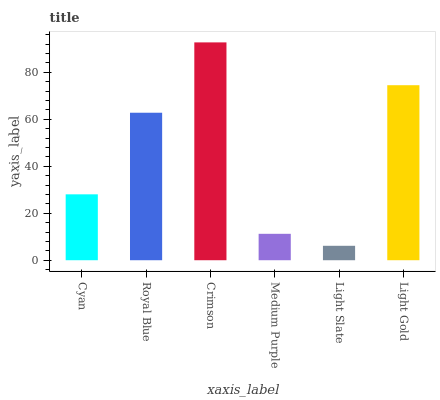Is Light Slate the minimum?
Answer yes or no. Yes. Is Crimson the maximum?
Answer yes or no. Yes. Is Royal Blue the minimum?
Answer yes or no. No. Is Royal Blue the maximum?
Answer yes or no. No. Is Royal Blue greater than Cyan?
Answer yes or no. Yes. Is Cyan less than Royal Blue?
Answer yes or no. Yes. Is Cyan greater than Royal Blue?
Answer yes or no. No. Is Royal Blue less than Cyan?
Answer yes or no. No. Is Royal Blue the high median?
Answer yes or no. Yes. Is Cyan the low median?
Answer yes or no. Yes. Is Medium Purple the high median?
Answer yes or no. No. Is Light Gold the low median?
Answer yes or no. No. 